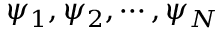<formula> <loc_0><loc_0><loc_500><loc_500>\psi _ { 1 } , \psi _ { 2 } , \cdots , \psi _ { N }</formula> 